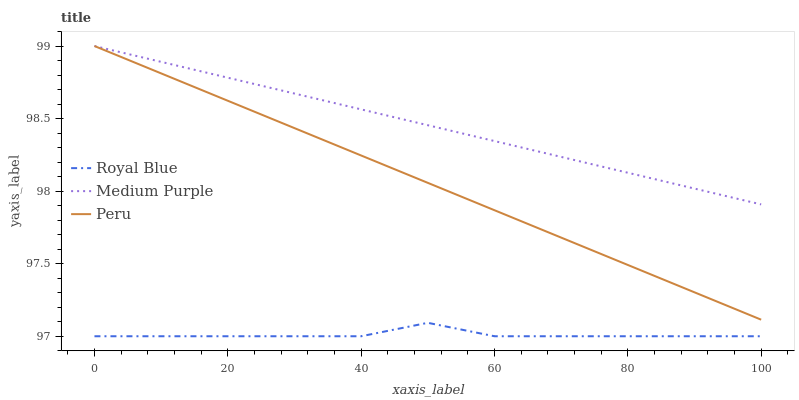Does Peru have the minimum area under the curve?
Answer yes or no. No. Does Peru have the maximum area under the curve?
Answer yes or no. No. Is Peru the smoothest?
Answer yes or no. No. Is Peru the roughest?
Answer yes or no. No. Does Peru have the lowest value?
Answer yes or no. No. Does Royal Blue have the highest value?
Answer yes or no. No. Is Royal Blue less than Peru?
Answer yes or no. Yes. Is Peru greater than Royal Blue?
Answer yes or no. Yes. Does Royal Blue intersect Peru?
Answer yes or no. No. 